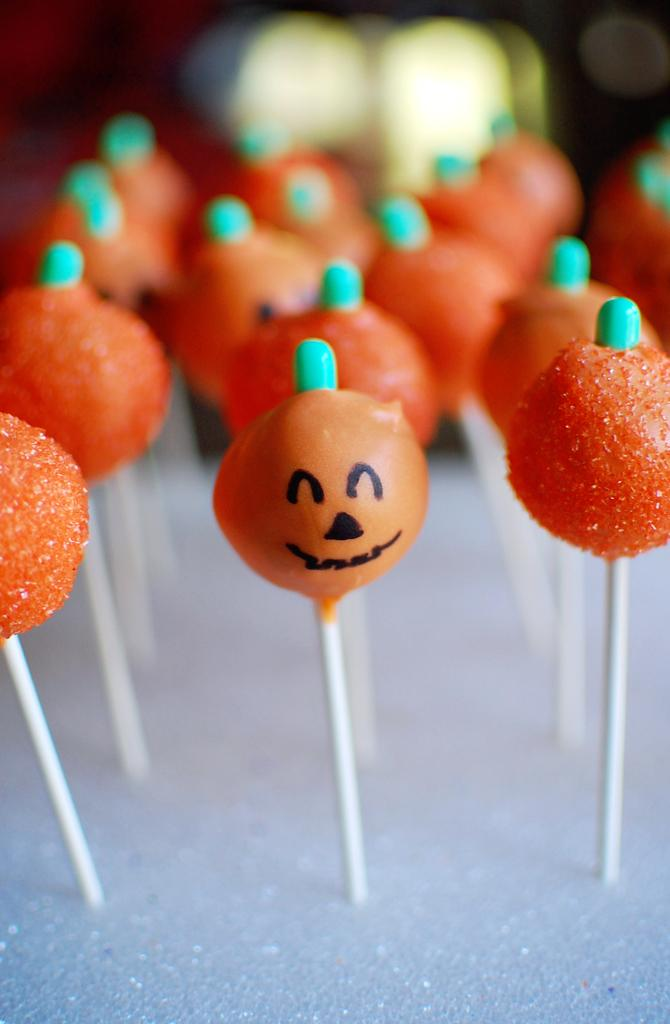What type of candy is visible in the image? There are orange lollipops in the image. What color is the surface on which the lollipops are placed? The lollipops are on a white surface. What type of disease is mentioned in the image? There is no mention of any disease in the image; it features orange lollipops on a white surface. 